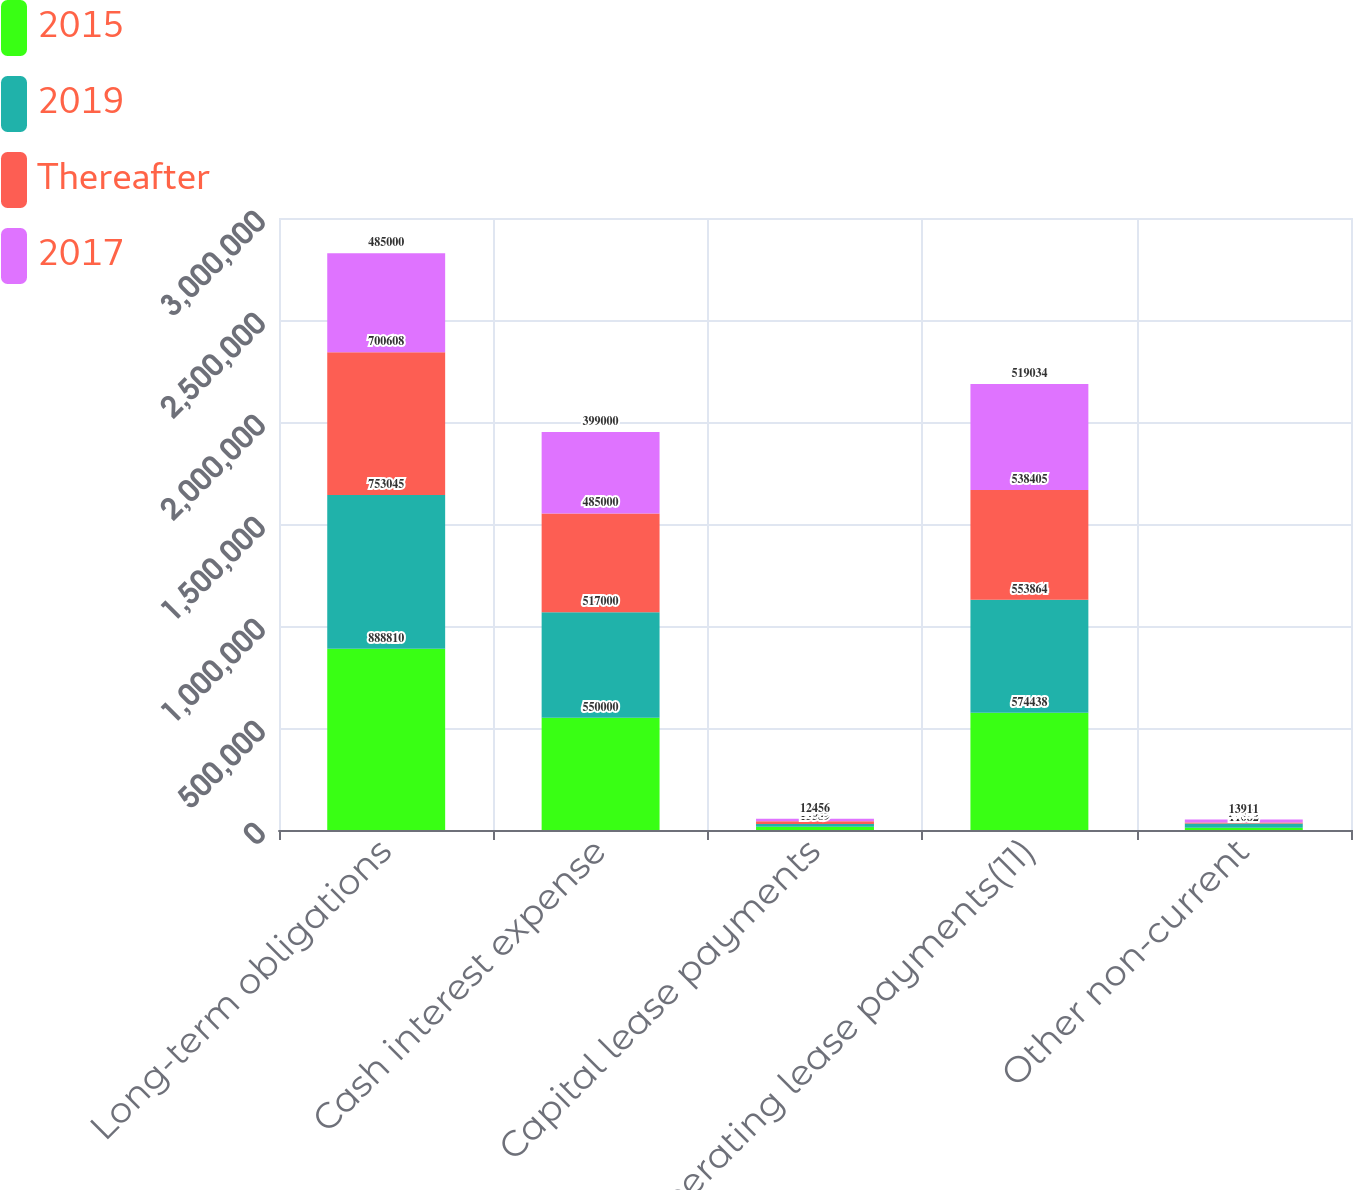<chart> <loc_0><loc_0><loc_500><loc_500><stacked_bar_chart><ecel><fcel>Long-term obligations<fcel>Cash interest expense<fcel>Capital lease payments<fcel>Operating lease payments(11)<fcel>Other non-current<nl><fcel>2015<fcel>888810<fcel>550000<fcel>15589<fcel>574438<fcel>11082<nl><fcel>2019<fcel>753045<fcel>517000<fcel>14049<fcel>553864<fcel>20480<nl><fcel>Thereafter<fcel>700608<fcel>485000<fcel>12905<fcel>538405<fcel>5705<nl><fcel>2017<fcel>485000<fcel>399000<fcel>12456<fcel>519034<fcel>13911<nl></chart> 